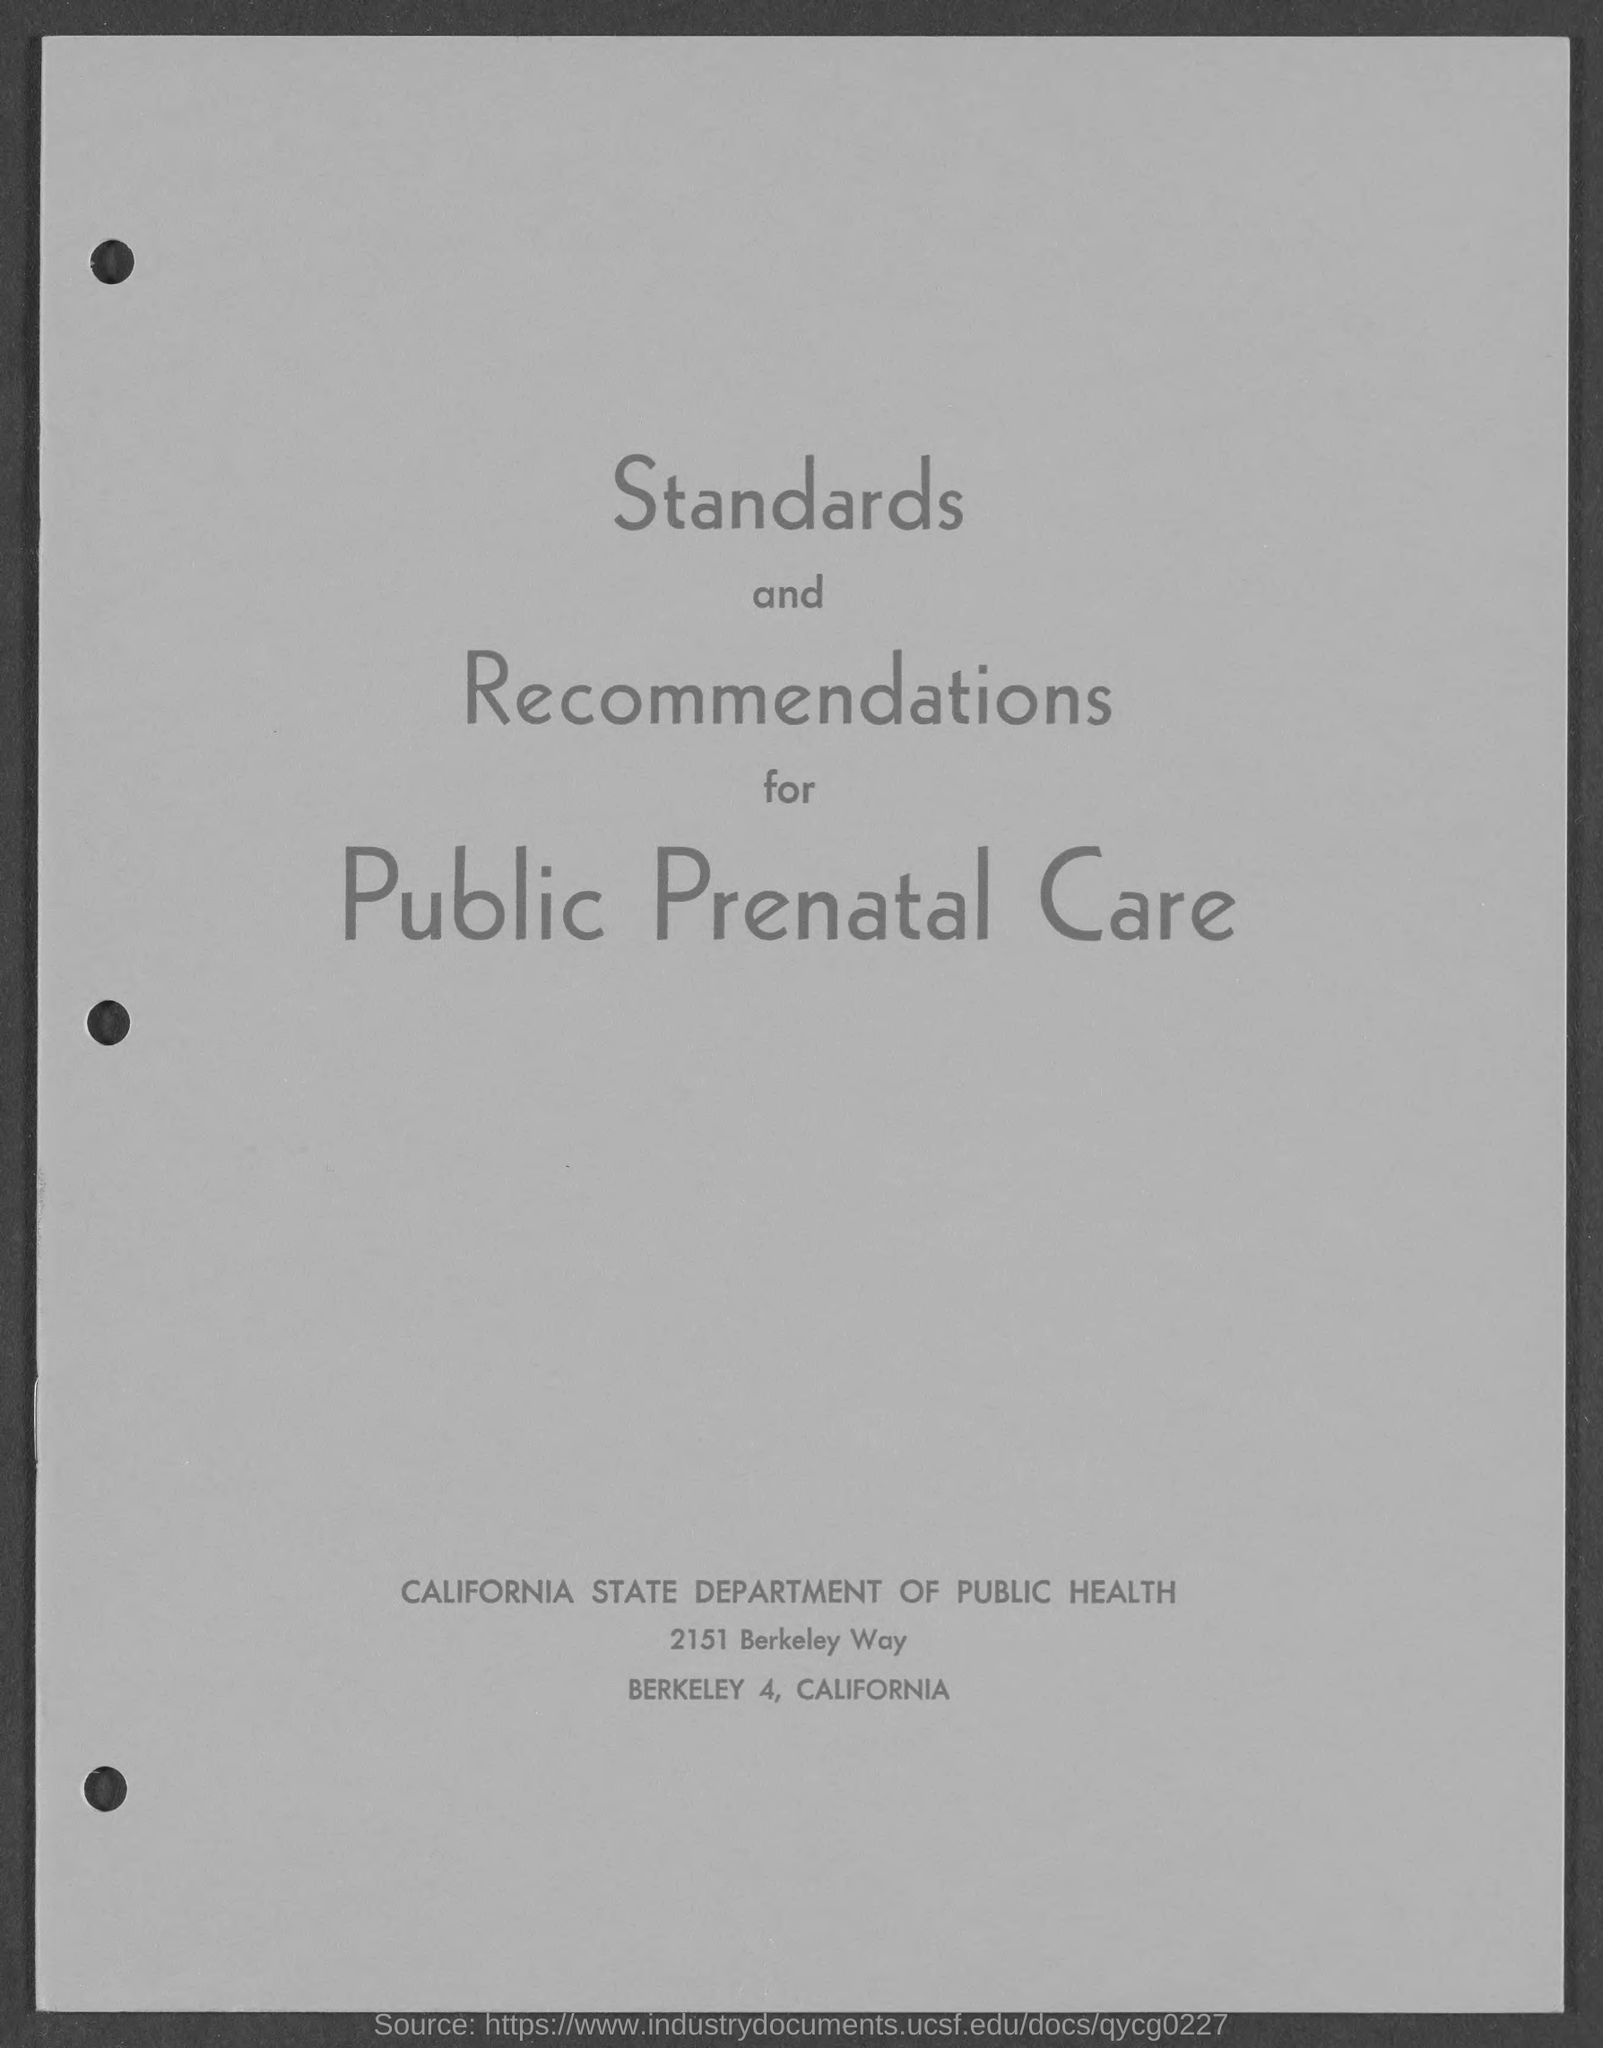Mention a couple of crucial points in this snapshot. The following standards and recommendations are given: Standards and Recommendations for Public Prenatal Care. 